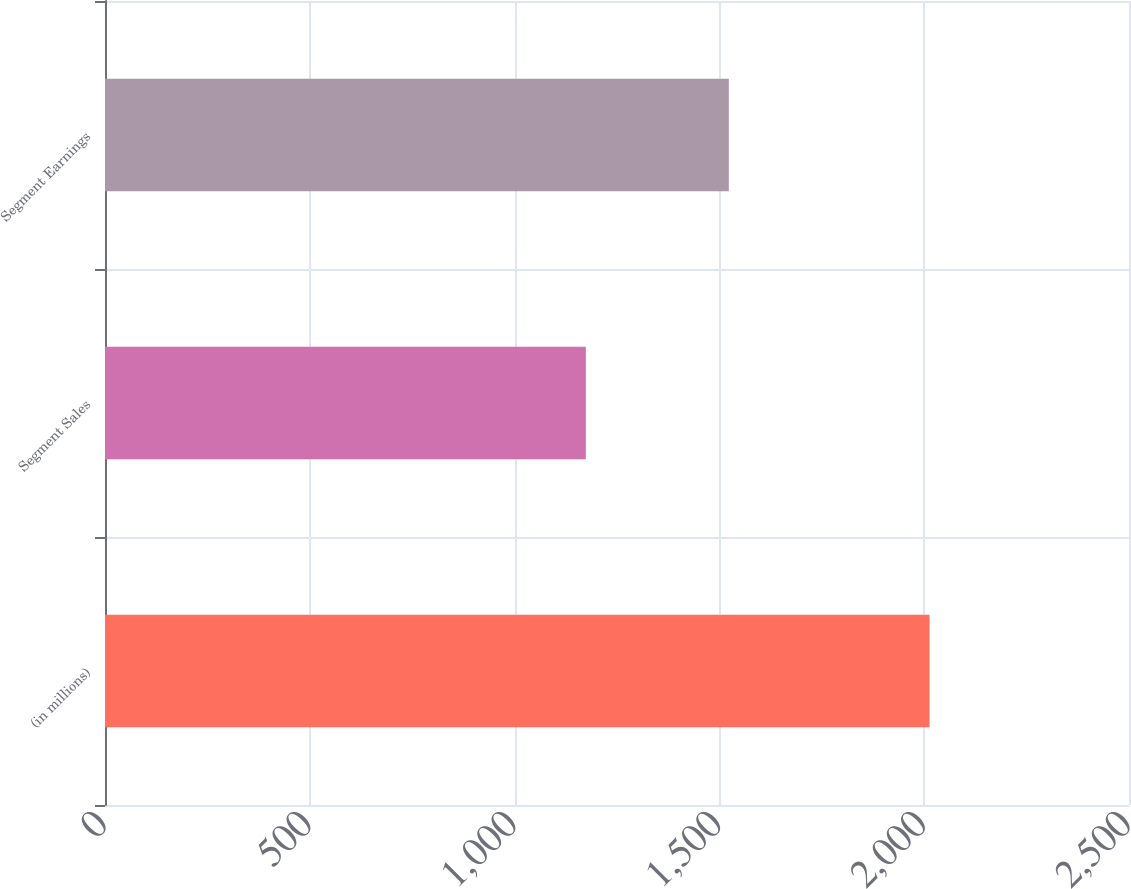Convert chart to OTSL. <chart><loc_0><loc_0><loc_500><loc_500><bar_chart><fcel>(in millions)<fcel>Segment Sales<fcel>Segment Earnings<nl><fcel>2013<fcel>1174<fcel>1523<nl></chart> 